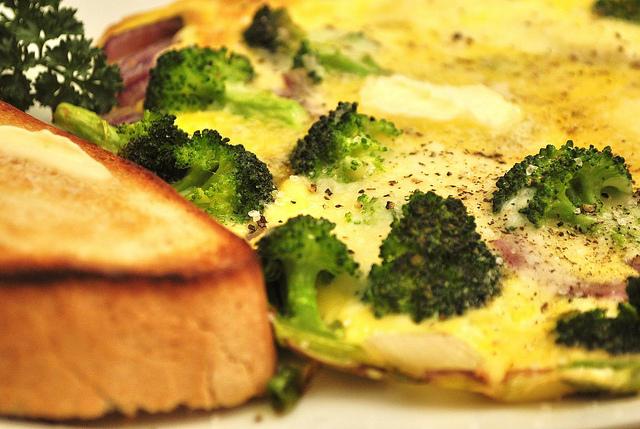Does this have cheese on it?
Short answer required. Yes. What is the green food?
Write a very short answer. Broccoli. Is there a carb-heavy component to this meal?
Concise answer only. Yes. 